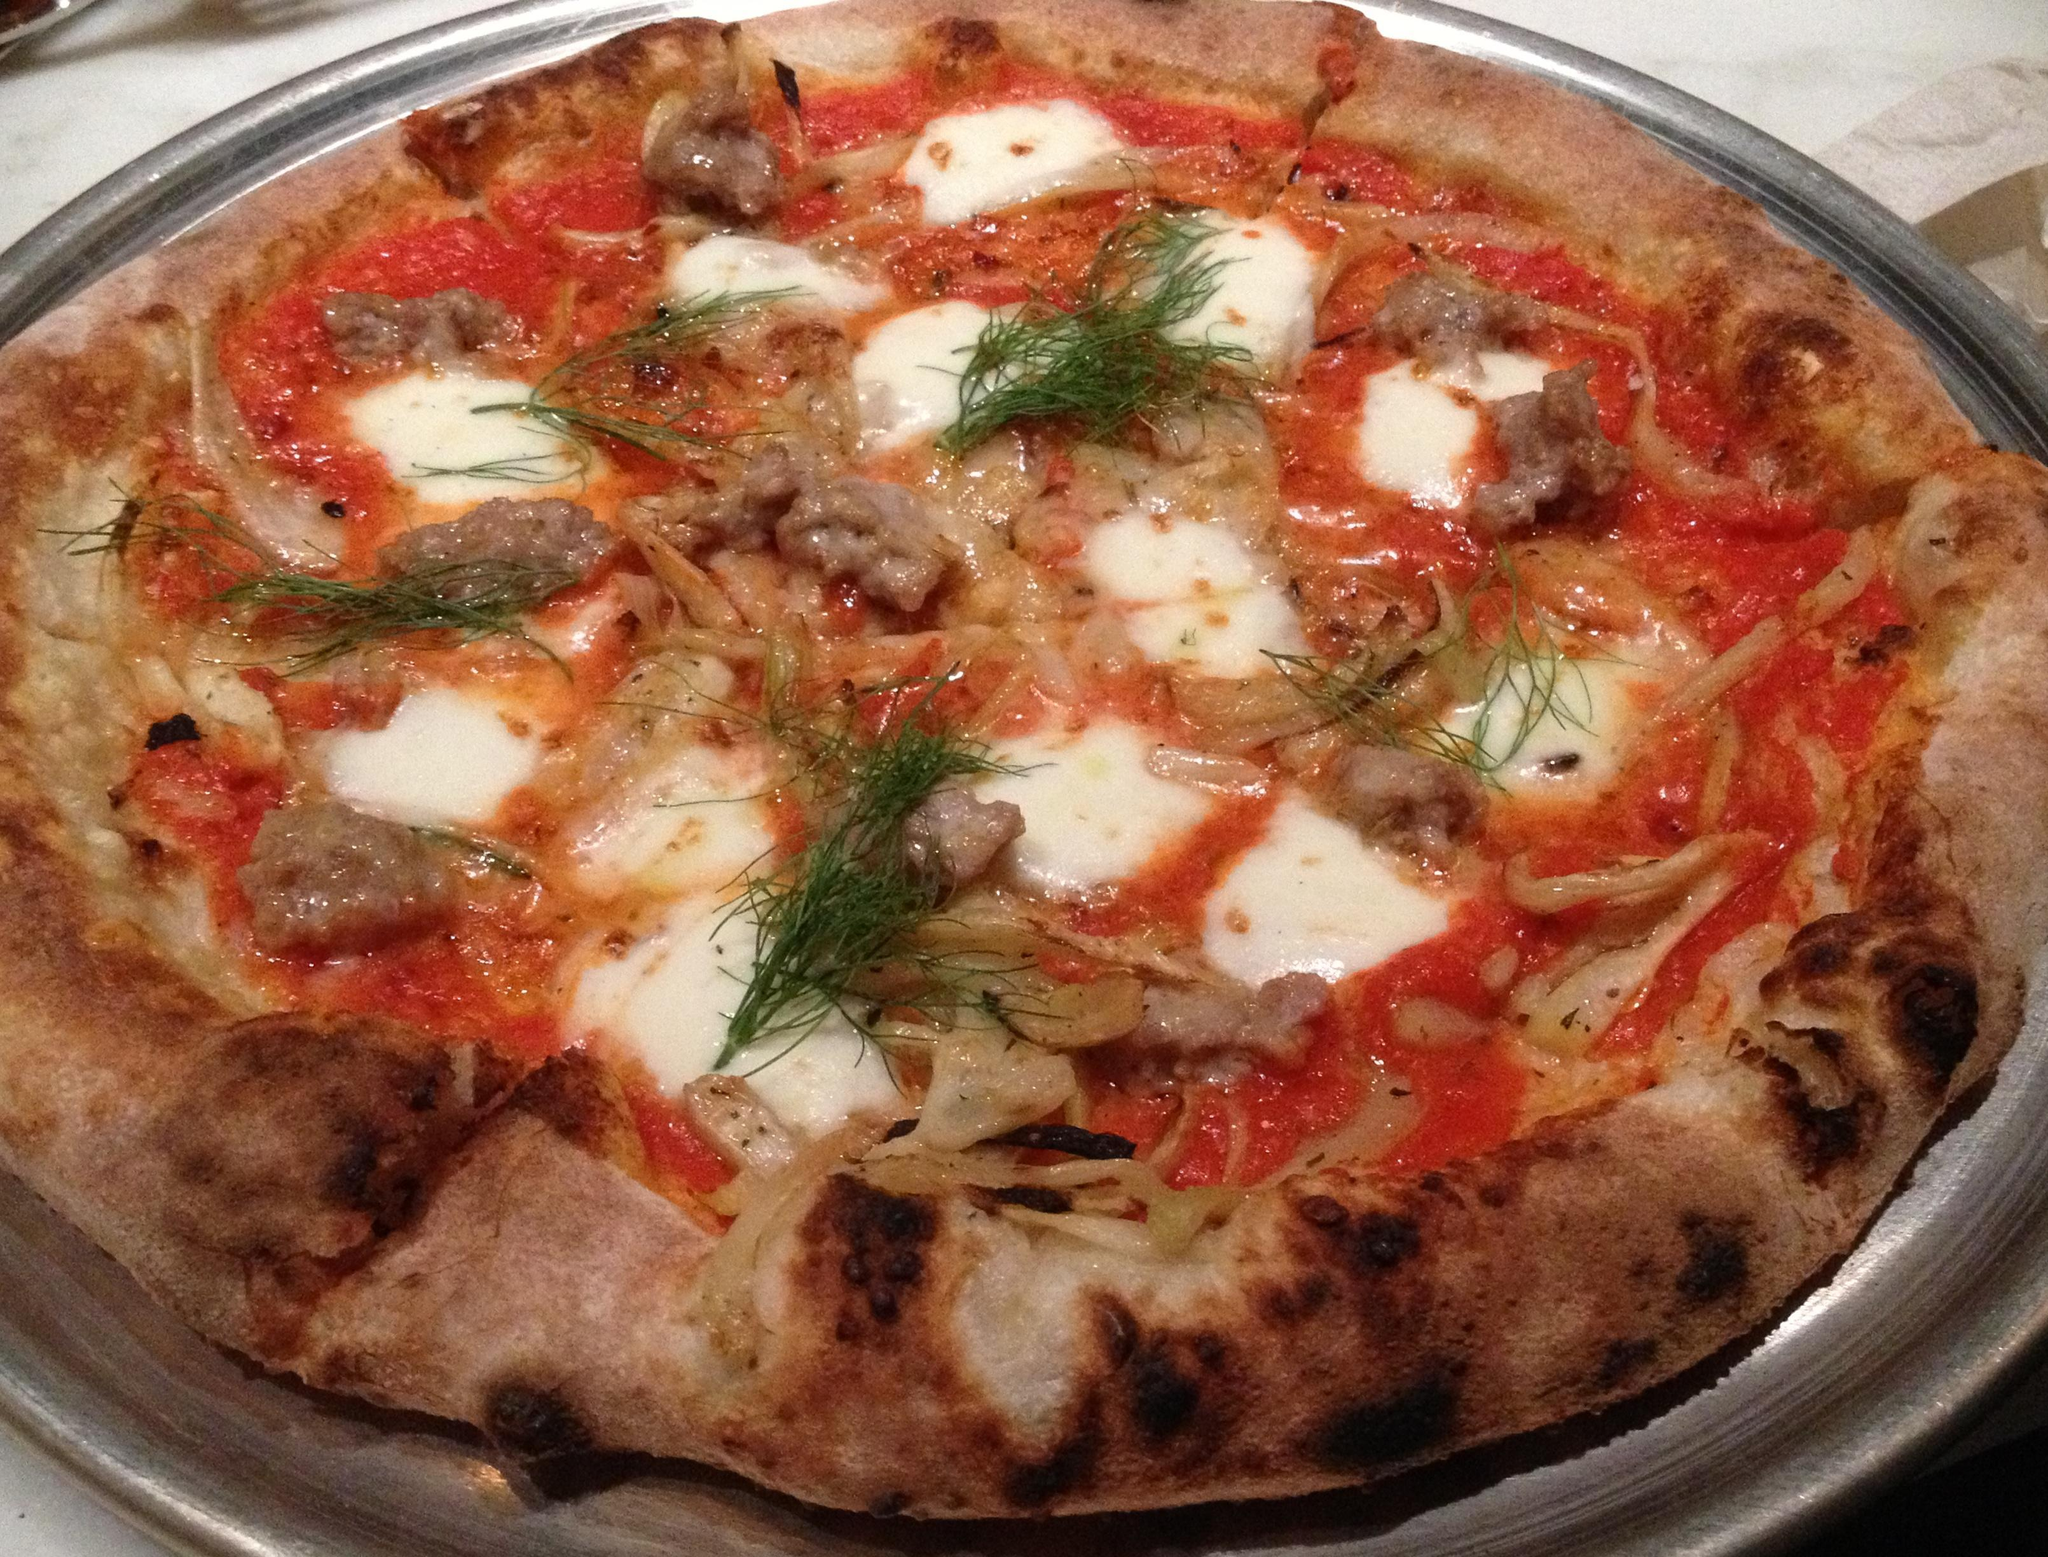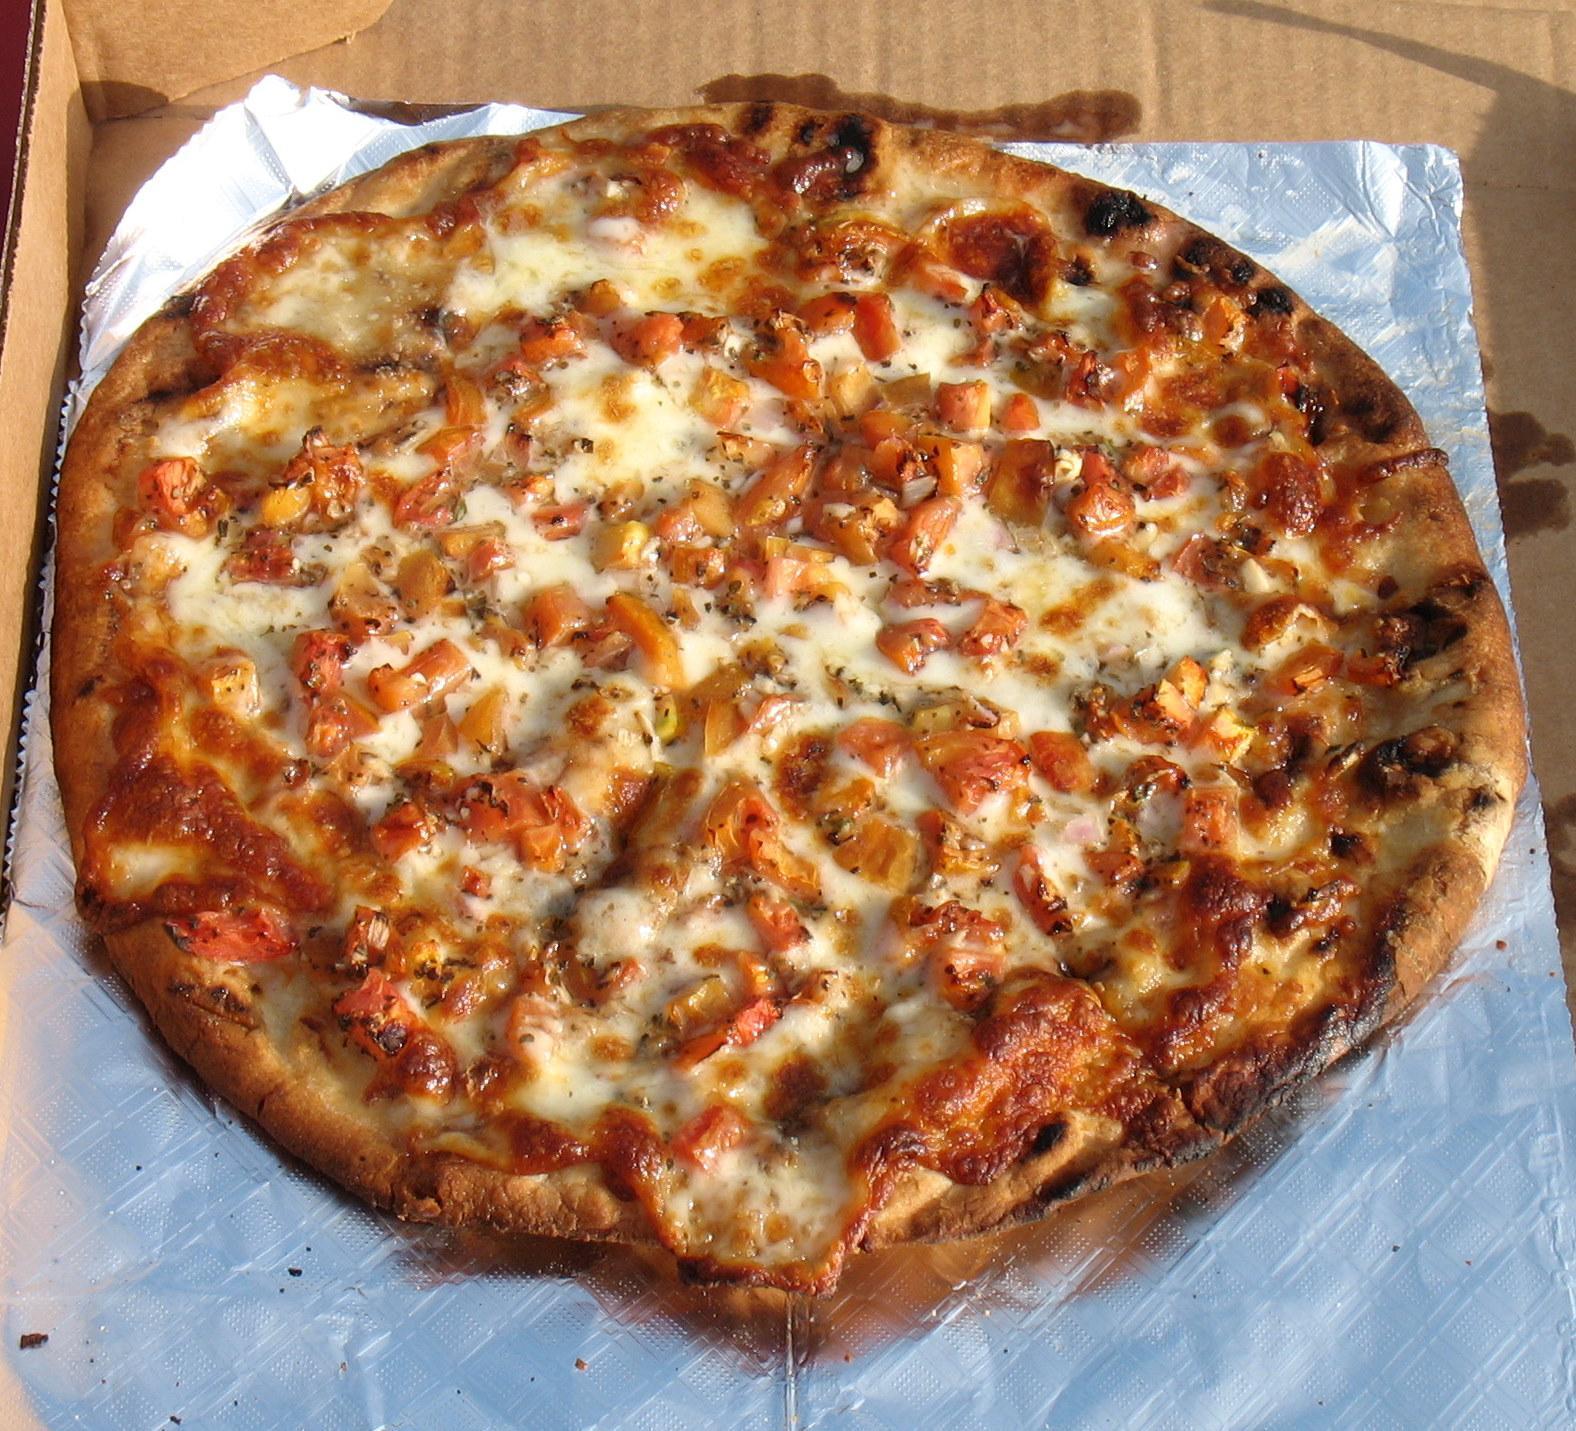The first image is the image on the left, the second image is the image on the right. Analyze the images presented: Is the assertion "Each image features a round pizza shape, and at least one image shows a pizza in a round metal dish." valid? Answer yes or no. Yes. The first image is the image on the left, the second image is the image on the right. For the images displayed, is the sentence "Both of the pizzas contain green parts." factually correct? Answer yes or no. No. 